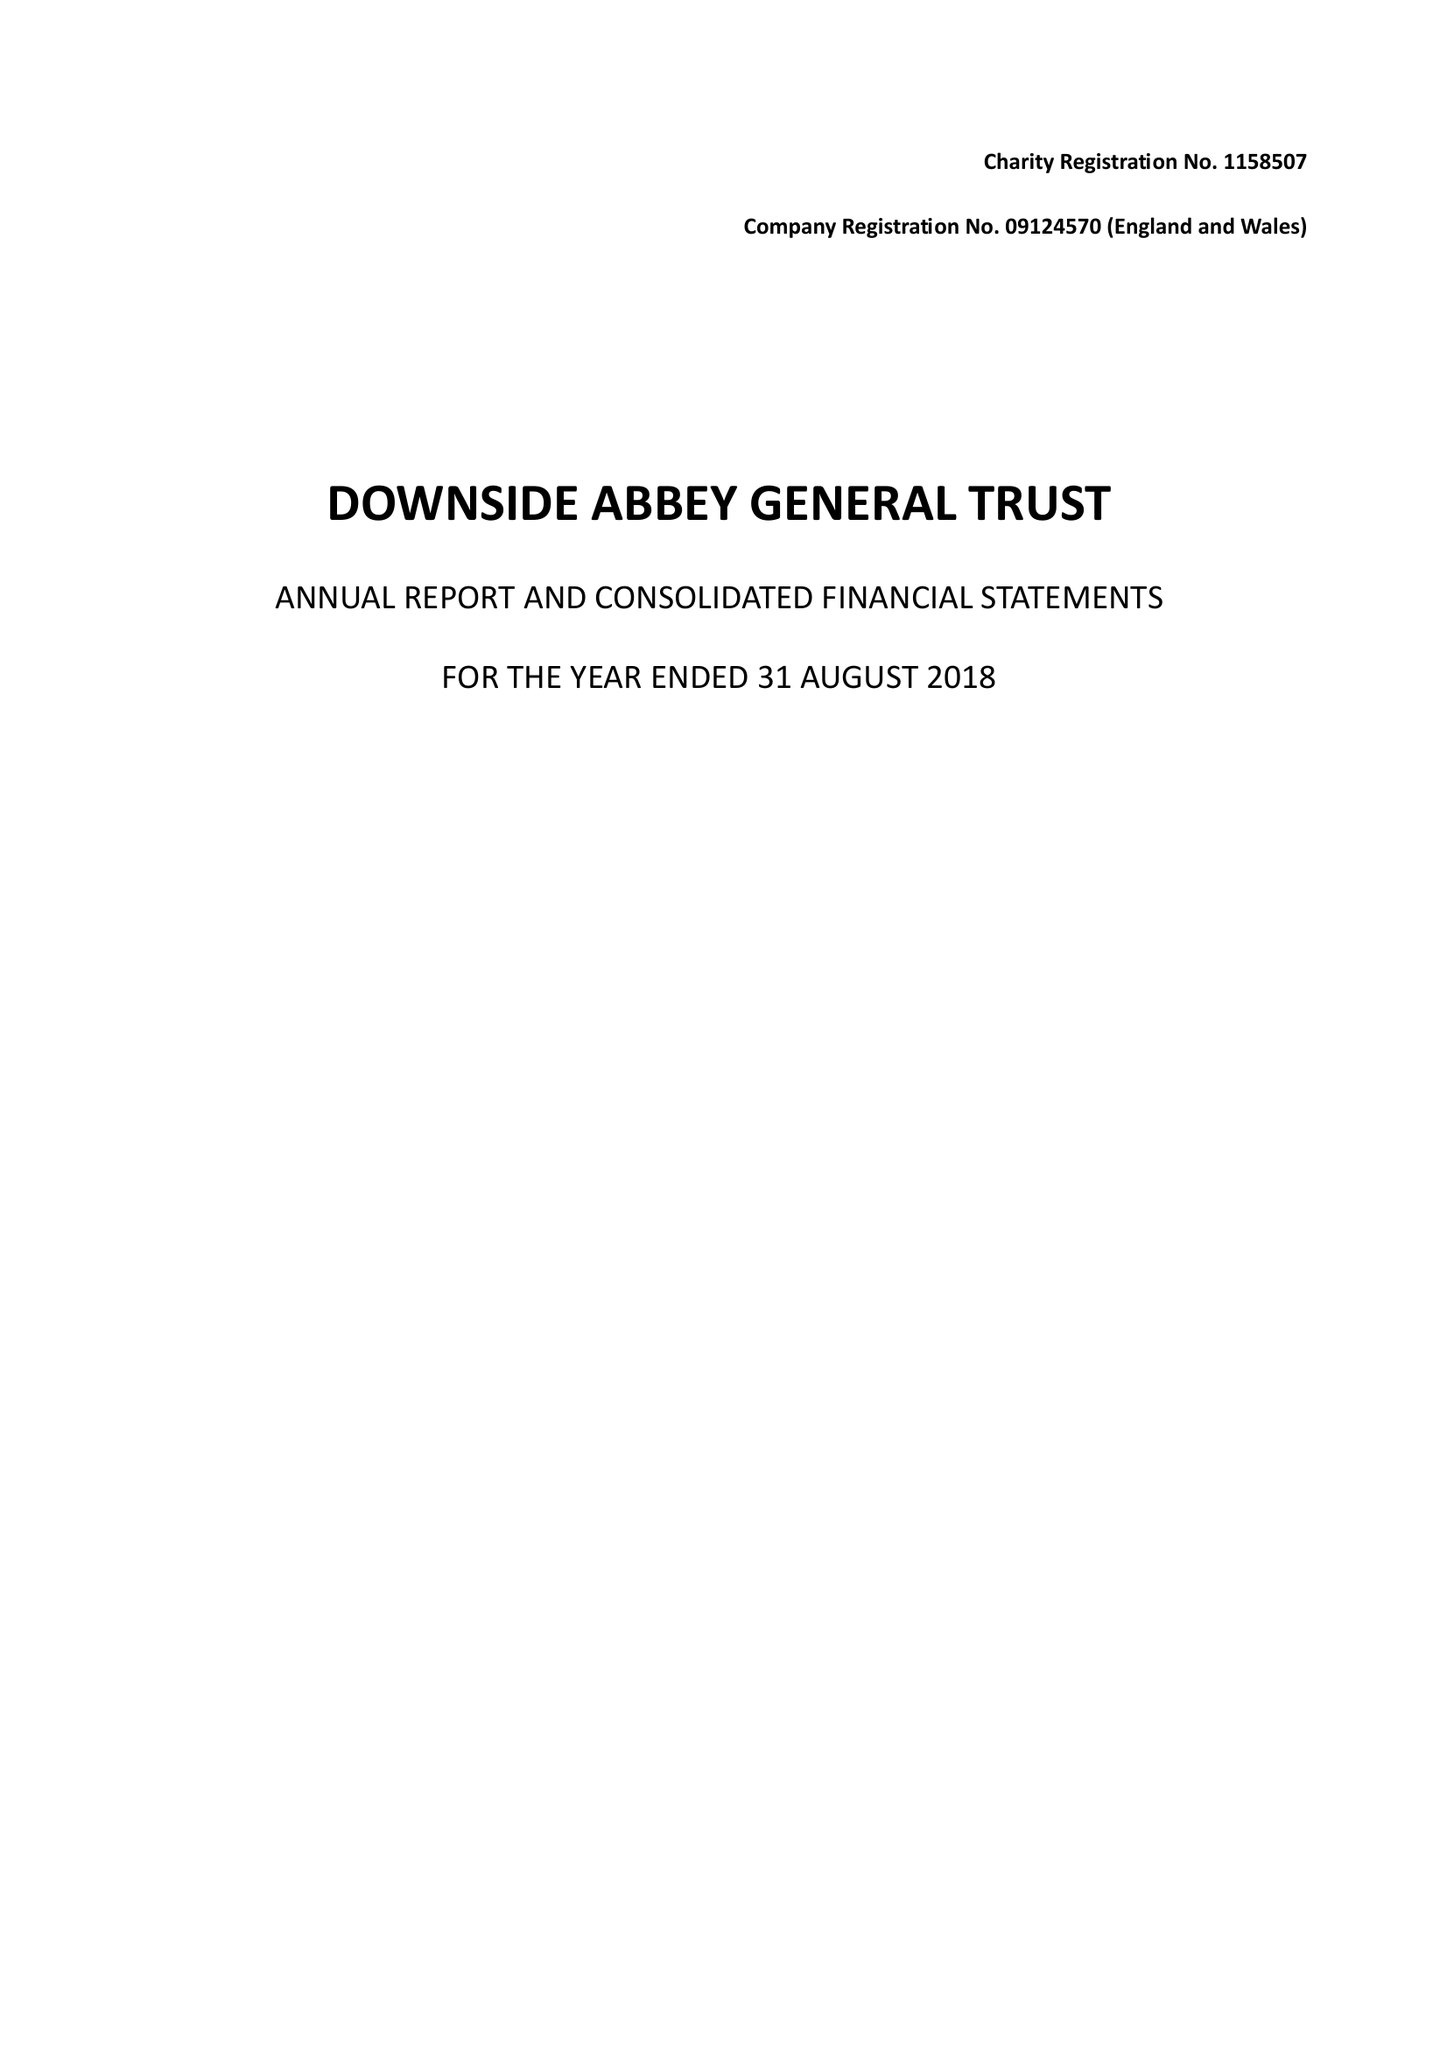What is the value for the income_annually_in_british_pounds?
Answer the question using a single word or phrase. 11759278.00 